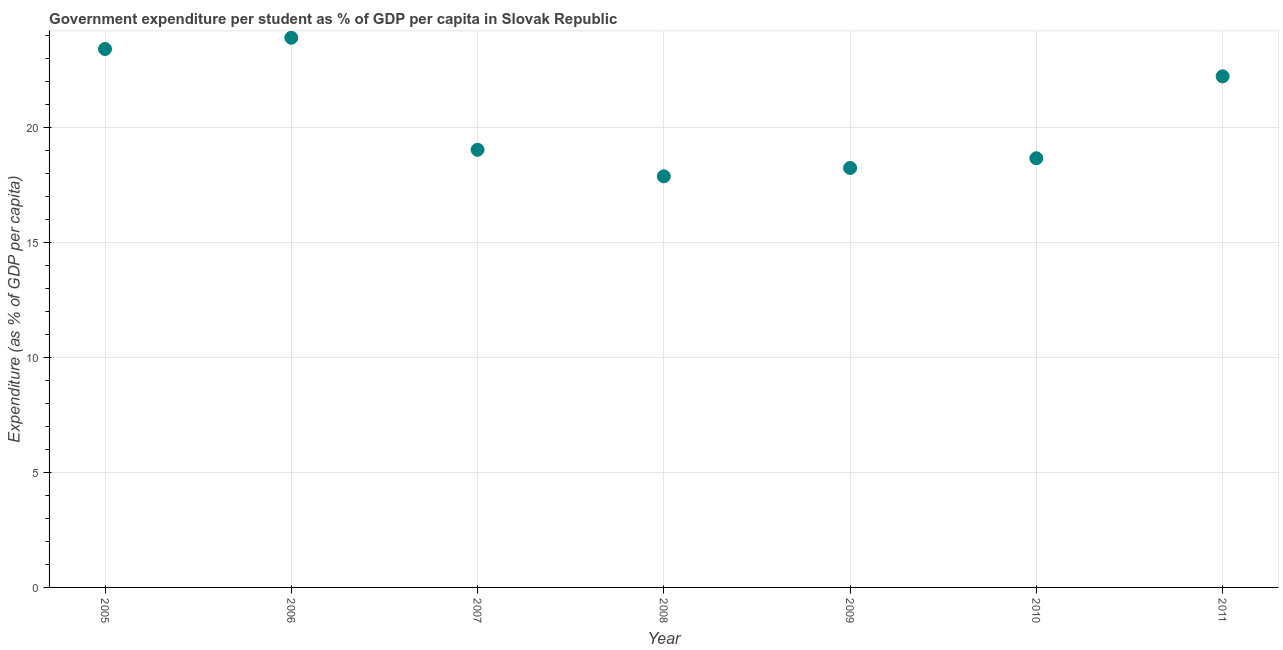What is the government expenditure per student in 2006?
Provide a short and direct response. 23.92. Across all years, what is the maximum government expenditure per student?
Provide a short and direct response. 23.92. Across all years, what is the minimum government expenditure per student?
Your answer should be very brief. 17.89. In which year was the government expenditure per student maximum?
Give a very brief answer. 2006. In which year was the government expenditure per student minimum?
Your response must be concise. 2008. What is the sum of the government expenditure per student?
Provide a short and direct response. 143.43. What is the difference between the government expenditure per student in 2007 and 2008?
Give a very brief answer. 1.16. What is the average government expenditure per student per year?
Provide a succinct answer. 20.49. What is the median government expenditure per student?
Offer a terse response. 19.04. In how many years, is the government expenditure per student greater than 2 %?
Your answer should be very brief. 7. Do a majority of the years between 2006 and 2007 (inclusive) have government expenditure per student greater than 18 %?
Your answer should be compact. Yes. What is the ratio of the government expenditure per student in 2007 to that in 2010?
Ensure brevity in your answer.  1.02. Is the difference between the government expenditure per student in 2005 and 2010 greater than the difference between any two years?
Your answer should be very brief. No. What is the difference between the highest and the second highest government expenditure per student?
Make the answer very short. 0.49. Is the sum of the government expenditure per student in 2006 and 2008 greater than the maximum government expenditure per student across all years?
Keep it short and to the point. Yes. What is the difference between the highest and the lowest government expenditure per student?
Make the answer very short. 6.03. How many years are there in the graph?
Your answer should be compact. 7. Are the values on the major ticks of Y-axis written in scientific E-notation?
Your response must be concise. No. Does the graph contain any zero values?
Your answer should be compact. No. What is the title of the graph?
Give a very brief answer. Government expenditure per student as % of GDP per capita in Slovak Republic. What is the label or title of the X-axis?
Ensure brevity in your answer.  Year. What is the label or title of the Y-axis?
Make the answer very short. Expenditure (as % of GDP per capita). What is the Expenditure (as % of GDP per capita) in 2005?
Provide a succinct answer. 23.43. What is the Expenditure (as % of GDP per capita) in 2006?
Give a very brief answer. 23.92. What is the Expenditure (as % of GDP per capita) in 2007?
Make the answer very short. 19.04. What is the Expenditure (as % of GDP per capita) in 2008?
Keep it short and to the point. 17.89. What is the Expenditure (as % of GDP per capita) in 2009?
Offer a very short reply. 18.25. What is the Expenditure (as % of GDP per capita) in 2010?
Offer a very short reply. 18.67. What is the Expenditure (as % of GDP per capita) in 2011?
Offer a very short reply. 22.24. What is the difference between the Expenditure (as % of GDP per capita) in 2005 and 2006?
Your response must be concise. -0.49. What is the difference between the Expenditure (as % of GDP per capita) in 2005 and 2007?
Your answer should be very brief. 4.38. What is the difference between the Expenditure (as % of GDP per capita) in 2005 and 2008?
Keep it short and to the point. 5.54. What is the difference between the Expenditure (as % of GDP per capita) in 2005 and 2009?
Your answer should be compact. 5.18. What is the difference between the Expenditure (as % of GDP per capita) in 2005 and 2010?
Your answer should be very brief. 4.75. What is the difference between the Expenditure (as % of GDP per capita) in 2005 and 2011?
Provide a succinct answer. 1.19. What is the difference between the Expenditure (as % of GDP per capita) in 2006 and 2007?
Keep it short and to the point. 4.87. What is the difference between the Expenditure (as % of GDP per capita) in 2006 and 2008?
Keep it short and to the point. 6.03. What is the difference between the Expenditure (as % of GDP per capita) in 2006 and 2009?
Ensure brevity in your answer.  5.66. What is the difference between the Expenditure (as % of GDP per capita) in 2006 and 2010?
Make the answer very short. 5.24. What is the difference between the Expenditure (as % of GDP per capita) in 2006 and 2011?
Keep it short and to the point. 1.68. What is the difference between the Expenditure (as % of GDP per capita) in 2007 and 2008?
Keep it short and to the point. 1.16. What is the difference between the Expenditure (as % of GDP per capita) in 2007 and 2009?
Give a very brief answer. 0.79. What is the difference between the Expenditure (as % of GDP per capita) in 2007 and 2010?
Your answer should be very brief. 0.37. What is the difference between the Expenditure (as % of GDP per capita) in 2007 and 2011?
Give a very brief answer. -3.2. What is the difference between the Expenditure (as % of GDP per capita) in 2008 and 2009?
Your response must be concise. -0.36. What is the difference between the Expenditure (as % of GDP per capita) in 2008 and 2010?
Your response must be concise. -0.79. What is the difference between the Expenditure (as % of GDP per capita) in 2008 and 2011?
Keep it short and to the point. -4.35. What is the difference between the Expenditure (as % of GDP per capita) in 2009 and 2010?
Your answer should be very brief. -0.42. What is the difference between the Expenditure (as % of GDP per capita) in 2009 and 2011?
Offer a terse response. -3.99. What is the difference between the Expenditure (as % of GDP per capita) in 2010 and 2011?
Offer a very short reply. -3.56. What is the ratio of the Expenditure (as % of GDP per capita) in 2005 to that in 2007?
Make the answer very short. 1.23. What is the ratio of the Expenditure (as % of GDP per capita) in 2005 to that in 2008?
Your answer should be compact. 1.31. What is the ratio of the Expenditure (as % of GDP per capita) in 2005 to that in 2009?
Ensure brevity in your answer.  1.28. What is the ratio of the Expenditure (as % of GDP per capita) in 2005 to that in 2010?
Your answer should be compact. 1.25. What is the ratio of the Expenditure (as % of GDP per capita) in 2005 to that in 2011?
Provide a succinct answer. 1.05. What is the ratio of the Expenditure (as % of GDP per capita) in 2006 to that in 2007?
Your response must be concise. 1.26. What is the ratio of the Expenditure (as % of GDP per capita) in 2006 to that in 2008?
Offer a very short reply. 1.34. What is the ratio of the Expenditure (as % of GDP per capita) in 2006 to that in 2009?
Ensure brevity in your answer.  1.31. What is the ratio of the Expenditure (as % of GDP per capita) in 2006 to that in 2010?
Give a very brief answer. 1.28. What is the ratio of the Expenditure (as % of GDP per capita) in 2006 to that in 2011?
Provide a short and direct response. 1.07. What is the ratio of the Expenditure (as % of GDP per capita) in 2007 to that in 2008?
Provide a succinct answer. 1.06. What is the ratio of the Expenditure (as % of GDP per capita) in 2007 to that in 2009?
Provide a short and direct response. 1.04. What is the ratio of the Expenditure (as % of GDP per capita) in 2007 to that in 2010?
Keep it short and to the point. 1.02. What is the ratio of the Expenditure (as % of GDP per capita) in 2007 to that in 2011?
Offer a very short reply. 0.86. What is the ratio of the Expenditure (as % of GDP per capita) in 2008 to that in 2009?
Your response must be concise. 0.98. What is the ratio of the Expenditure (as % of GDP per capita) in 2008 to that in 2010?
Ensure brevity in your answer.  0.96. What is the ratio of the Expenditure (as % of GDP per capita) in 2008 to that in 2011?
Your answer should be compact. 0.8. What is the ratio of the Expenditure (as % of GDP per capita) in 2009 to that in 2010?
Provide a succinct answer. 0.98. What is the ratio of the Expenditure (as % of GDP per capita) in 2009 to that in 2011?
Give a very brief answer. 0.82. What is the ratio of the Expenditure (as % of GDP per capita) in 2010 to that in 2011?
Your response must be concise. 0.84. 